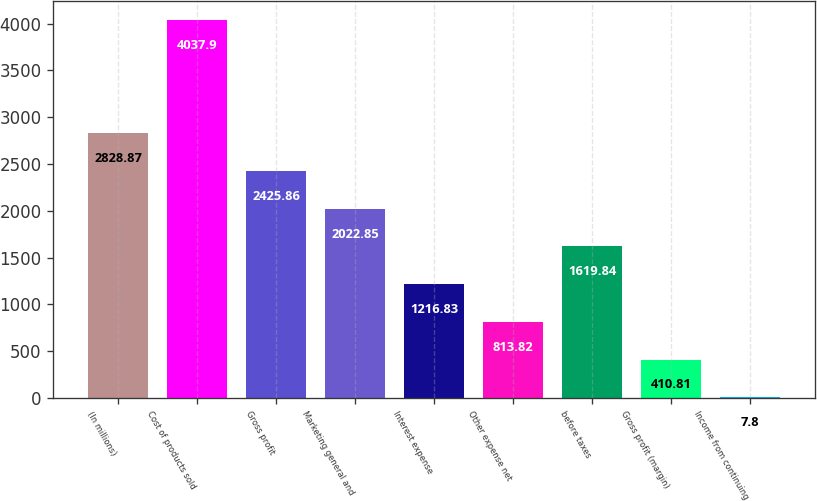Convert chart to OTSL. <chart><loc_0><loc_0><loc_500><loc_500><bar_chart><fcel>(In millions)<fcel>Cost of products sold<fcel>Gross profit<fcel>Marketing general and<fcel>Interest expense<fcel>Other expense net<fcel>before taxes<fcel>Gross profit (margin)<fcel>Income from continuing<nl><fcel>2828.87<fcel>4037.9<fcel>2425.86<fcel>2022.85<fcel>1216.83<fcel>813.82<fcel>1619.84<fcel>410.81<fcel>7.8<nl></chart> 